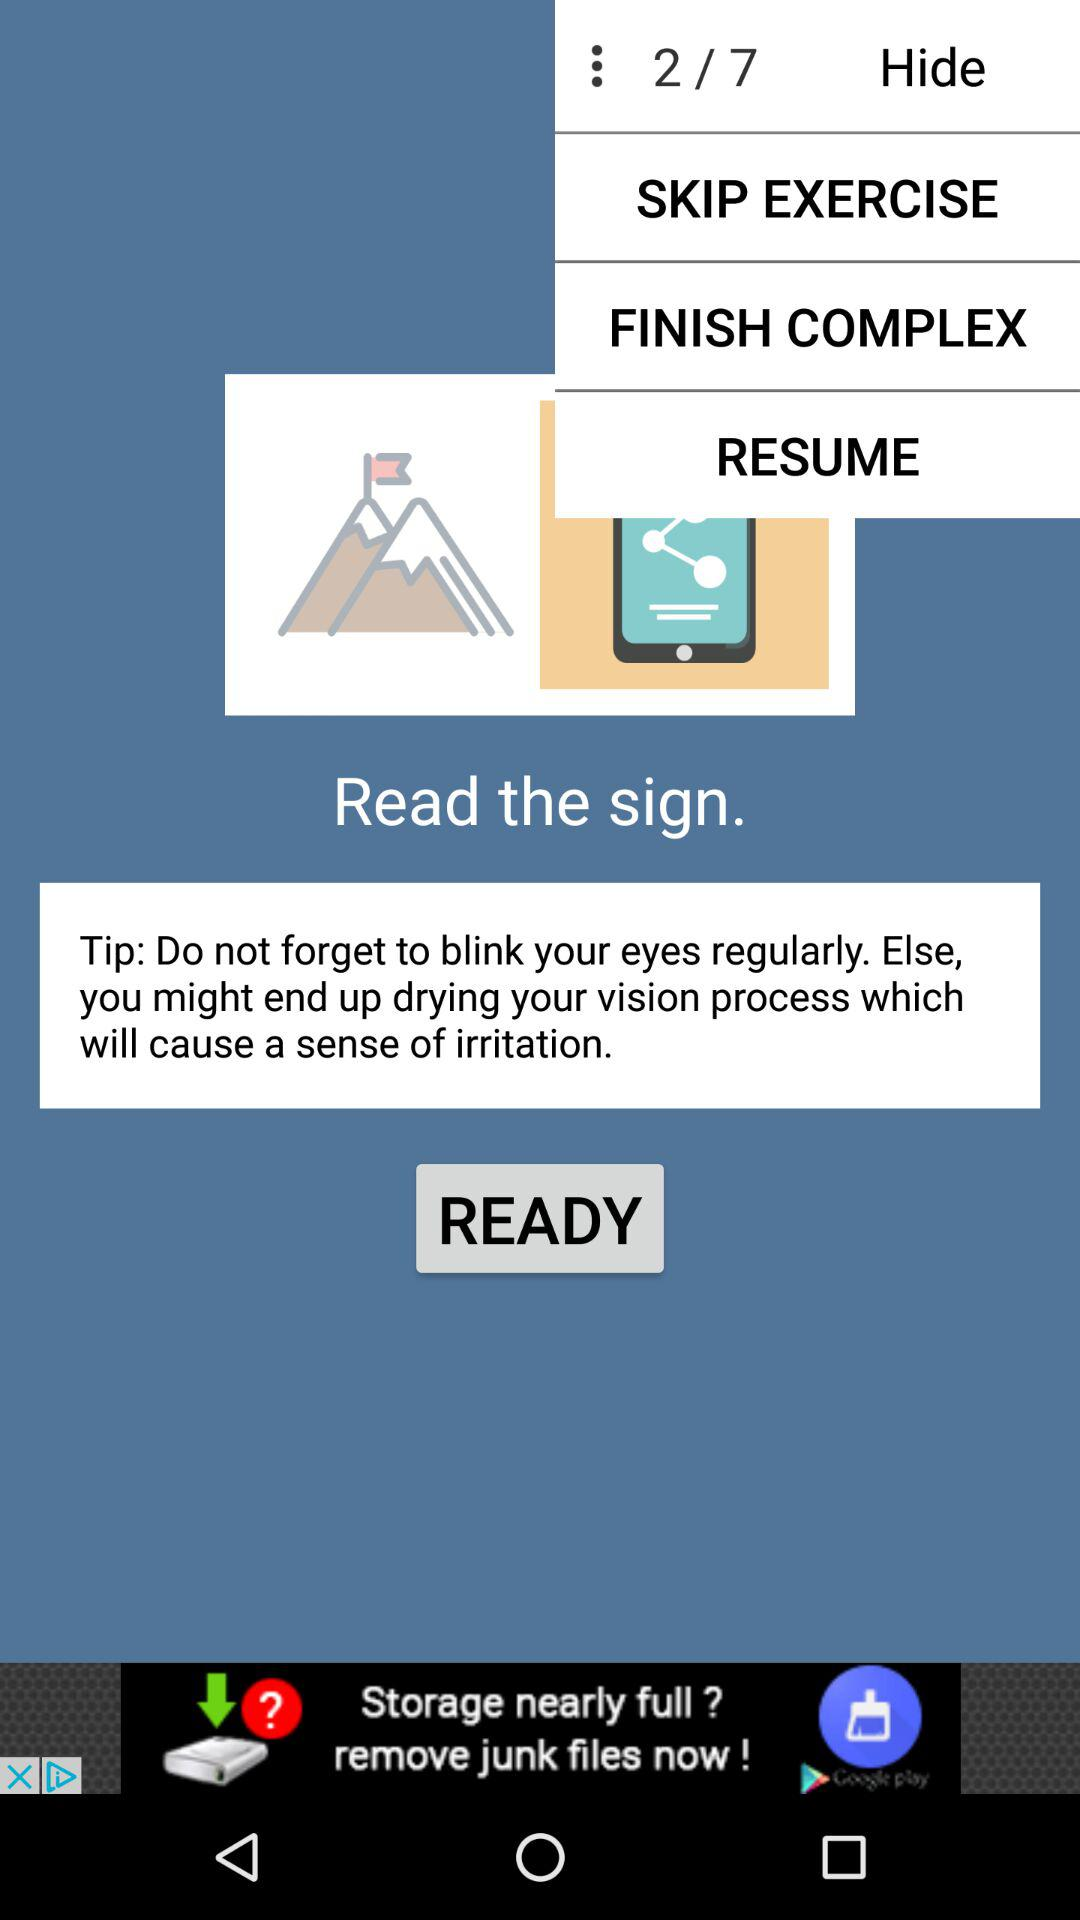Which exercise is the person currently on? The person is currently on the second exercise. 